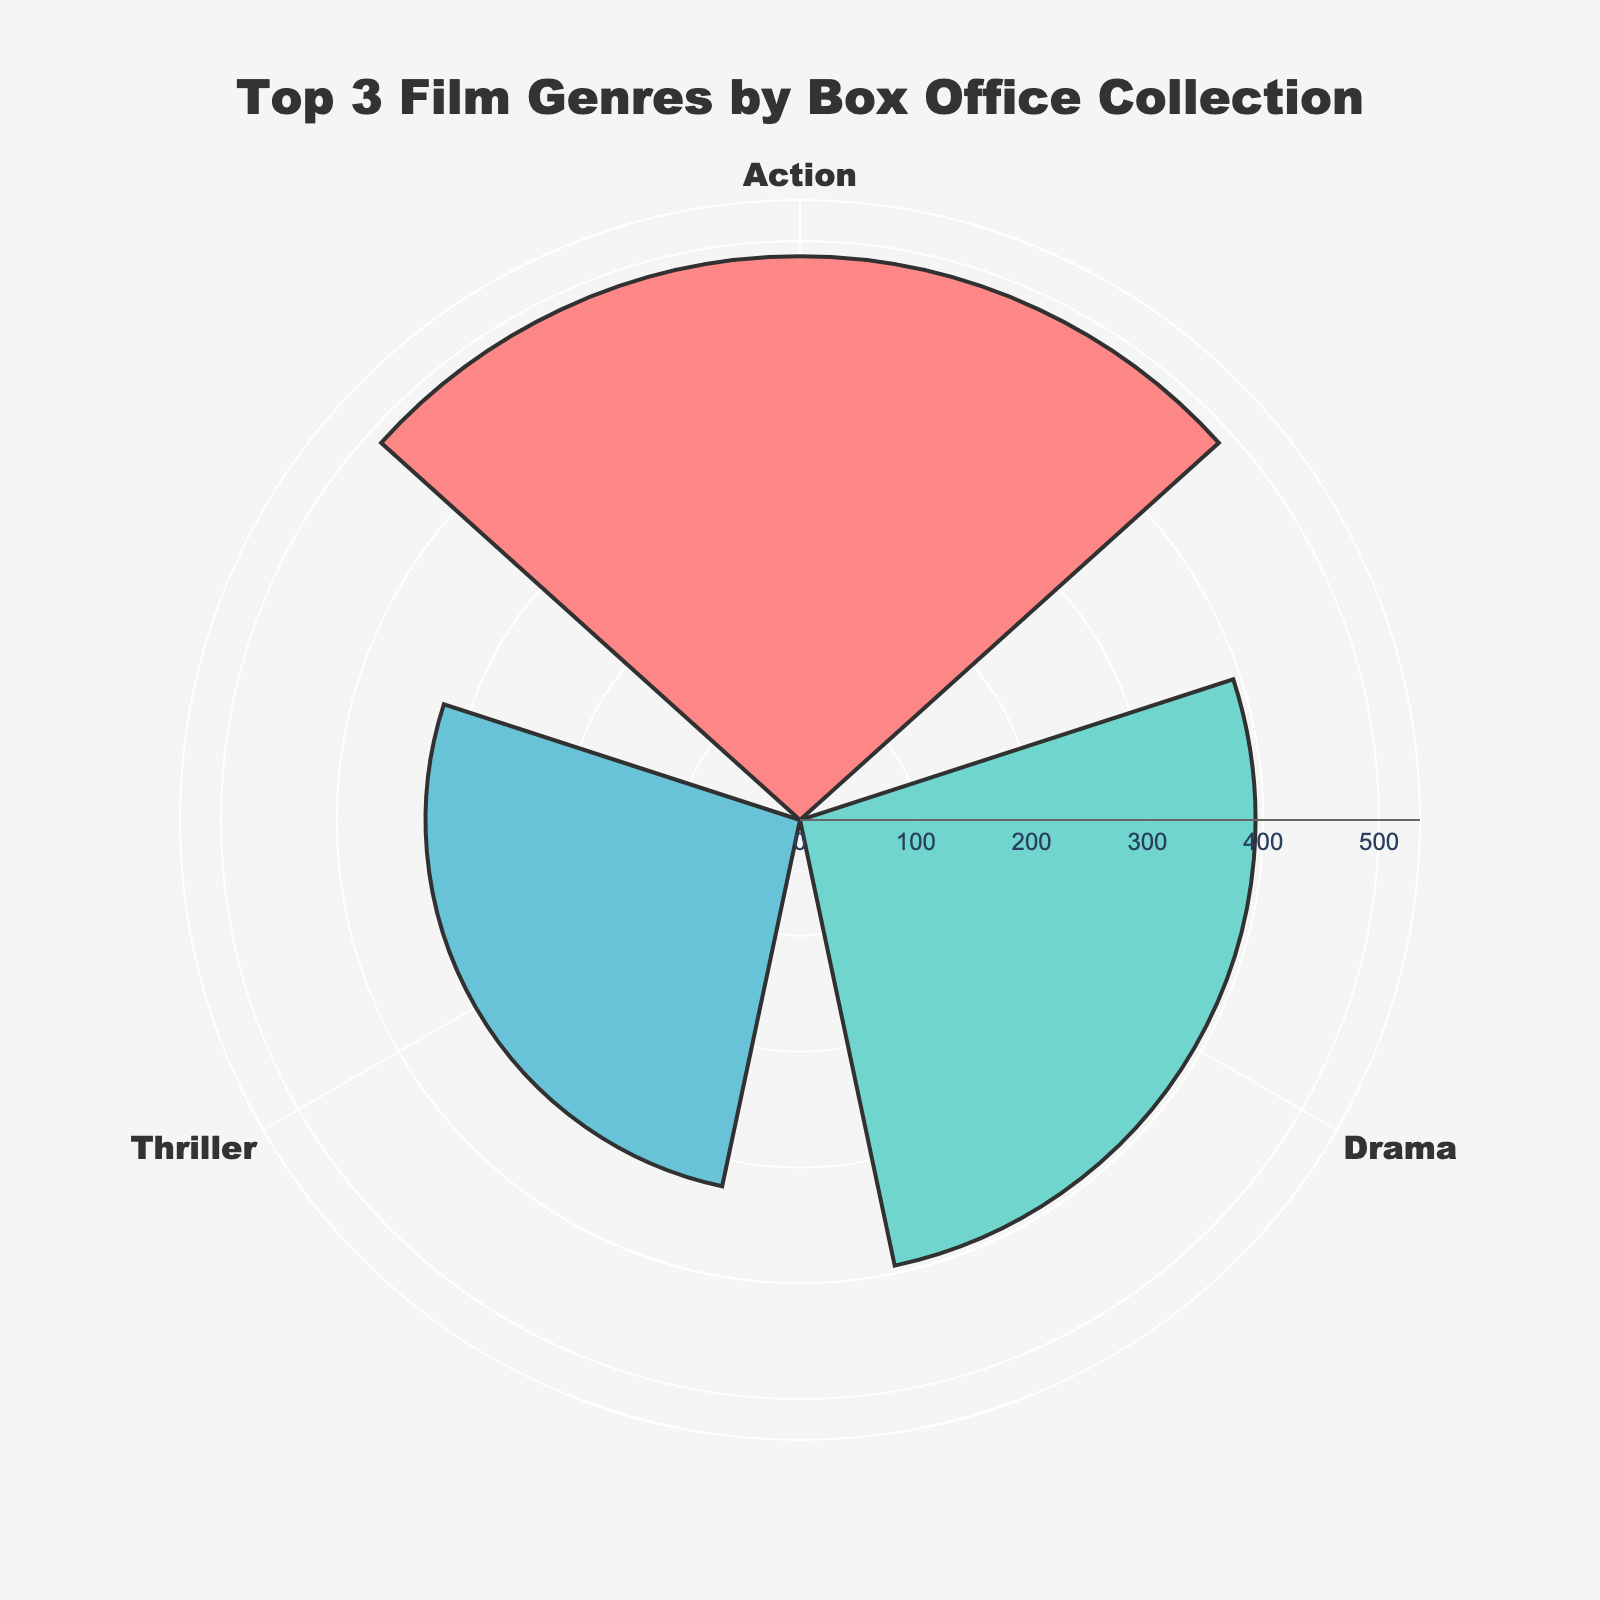what is the title of the chart? The title of the chart is typically one of the most noticeable elements at the top. In this case, the title is "Top 3 Film Genres by Box Office Collection"
Answer: Top 3 Film Genres by Box Office Collection what are the three genres represented in the chart? The genres are listed around the chart in correspondence with their respective collections. The three genres are "Action", "Drama", and "Thriller"
Answer: Action, Drama, Thriller which genre has the highest average box office collection? To determine the genre with the highest average box office collection, look for the longest bar facing outward from its center point. The "Action" genre has the highest value
Answer: Action how much is the average box office collection for the thriller genre? Locate the section labeled "Thriller." The length of the bar corresponding to "Thriller" reflects its average box office collection, which is around 323.33
Answer: 323.33 what is the difference in average box office collections between the action and drama genres? Identify the values for "Action" and "Drama". The collections are approximately 486.67 for "Action" and 393.33 for "Drama". The difference is 486.67 - 393.33
Answer: 93.34 which genre has the least average box office collection among the top three? To determine the genre with the smallest average box office collection, locate the genre with the shortest bar. "Thriller" has the least average box office collection among the top three
Answer: Thriller what are the colors used to represent each genre? Observing the chart, we can see that "Action" is represented in a red-like color, "Drama" in aqua green, and "Thriller" in blue
Answer: Red-like for Action, Aqua green for Drama, Blue for Thriller 